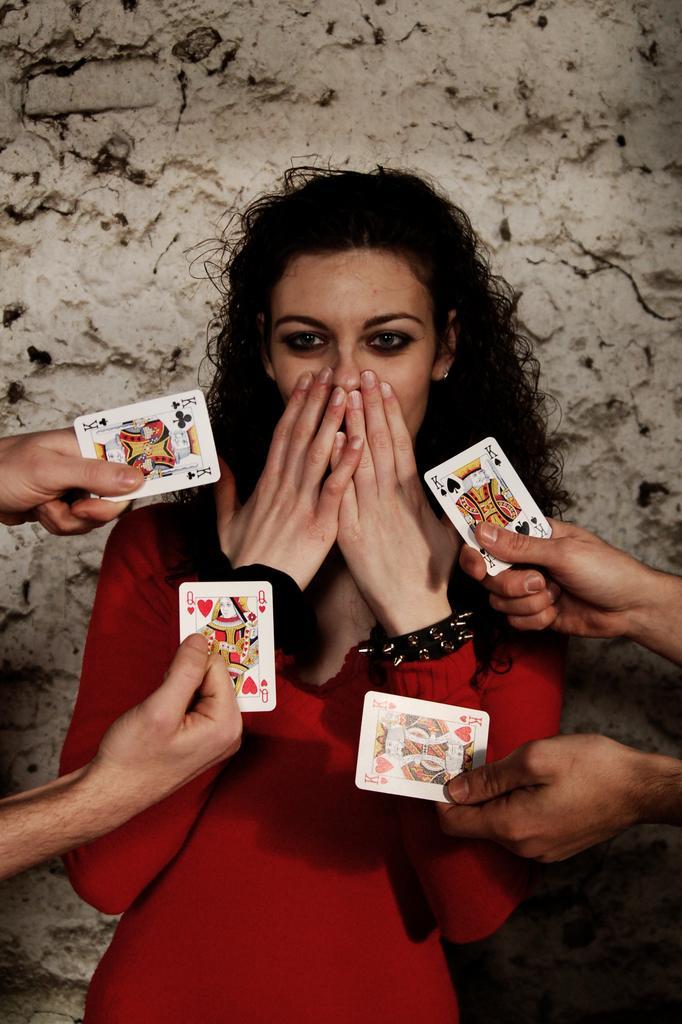Could you give a brief overview of what you see in this image? There is a woman in a red dress closing her mouth with her two hands and there are some members showing a playing cards to the women in their hands separately. We can observe a wall in the background. 